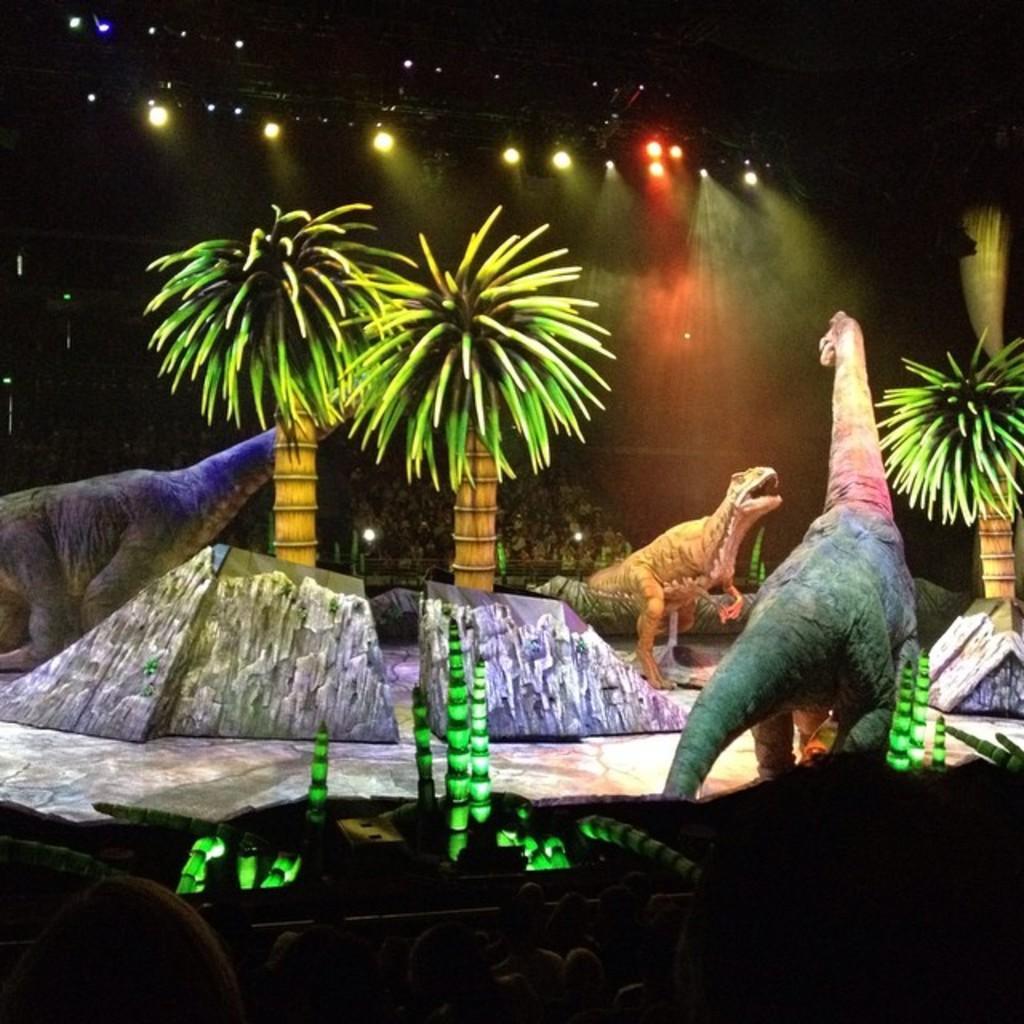Describe this image in one or two sentences. As we can see in the image there is drawing of trees, lights and animals. In the background there are few people. 